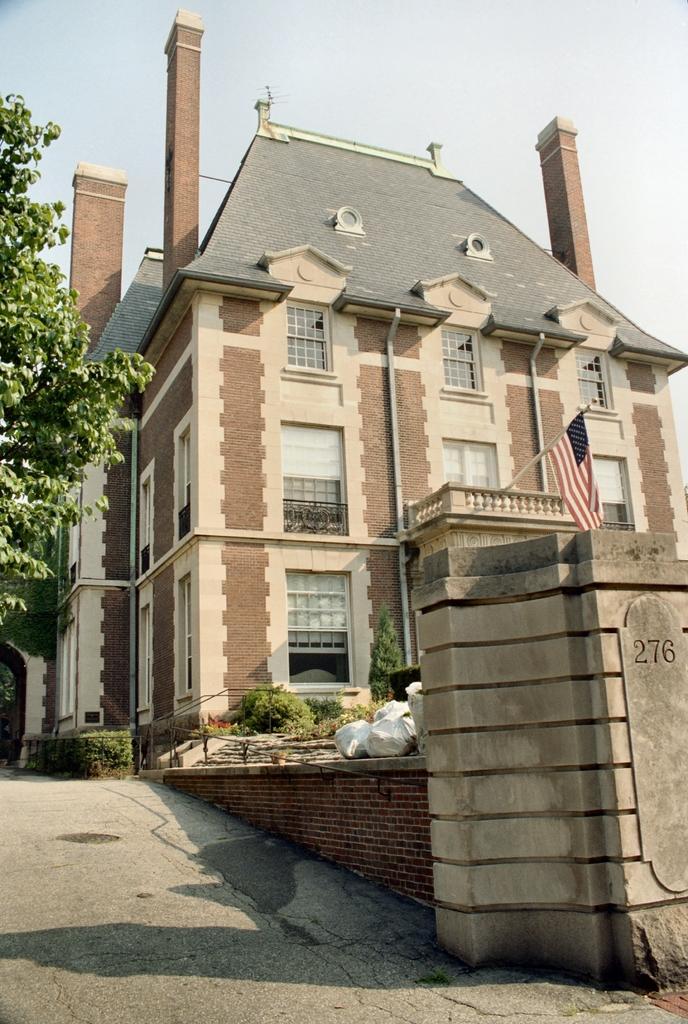Describe this image in one or two sentences. In this picture I can see the path in front and on the right side of this picture, I can see the wall and I see 3 numbers written. In the background I can see few plants, a tree and a building and I can also see a flag. On the top of this picture, I can see the clear sky. 